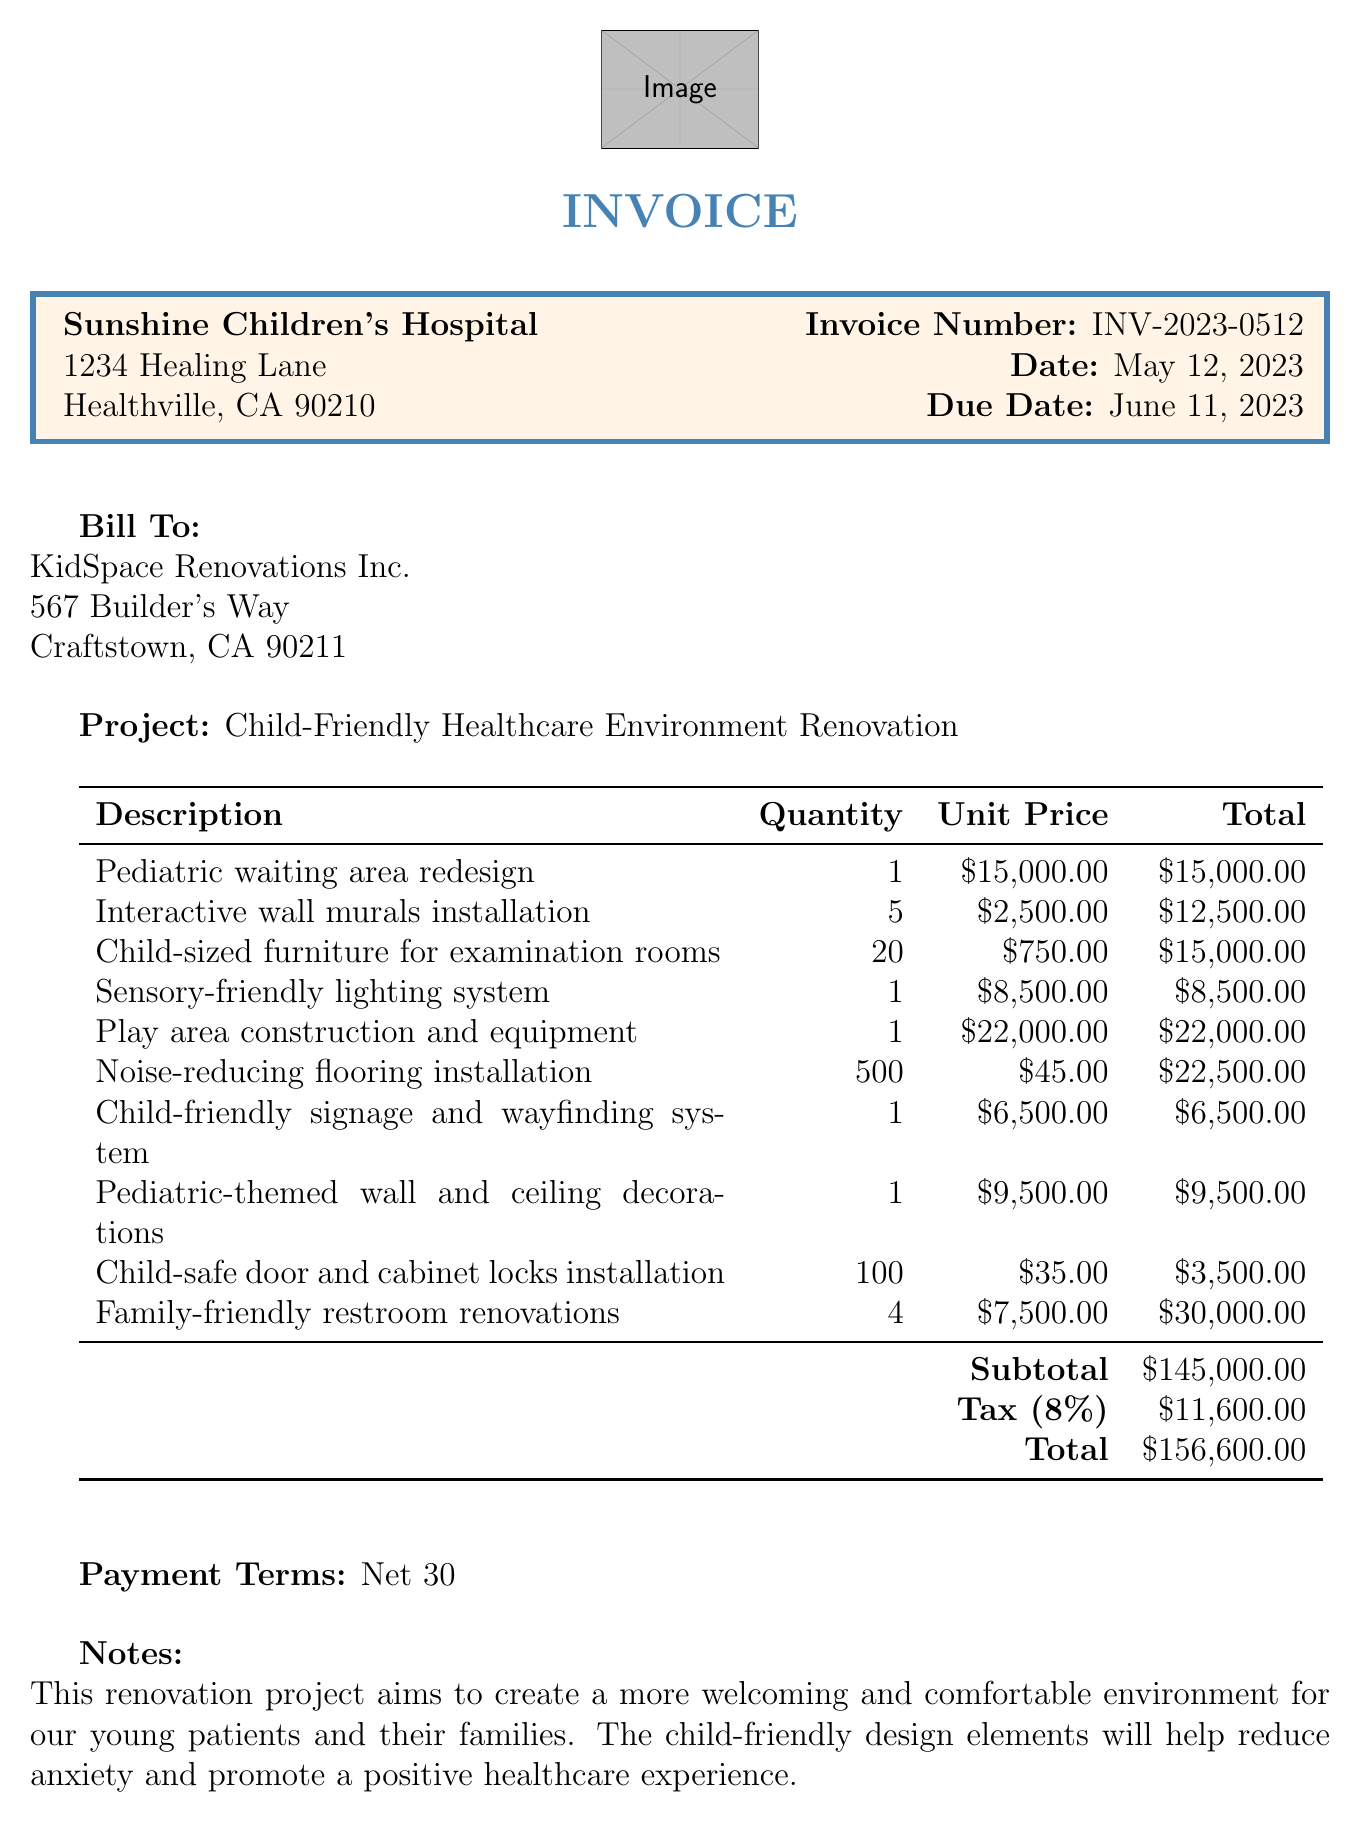What is the invoice number? The invoice number is listed clearly in the document, which is INV-2023-0512.
Answer: INV-2023-0512 What is the total amount for the renovation project? The total amount is summarized at the end of the line item details, amounting to $156,600.
Answer: $156,600 How many family-friendly restroom renovations are included? Family-friendly restroom renovations are listed as having a quantity of 4 in the line items.
Answer: 4 What is the tax rate applied to the subtotal? The tax rate of 8% is specified in the tax calculation section of the document.
Answer: 8% Who is the project manager? The project manager's name is given at the bottom of the document, which is Emily Thompson.
Answer: Emily Thompson What is the due date for the invoice payment? The due date for payment is clearly stated as June 11, 2023, in the document.
Answer: June 11, 2023 How many child-safe door and cabinet locks were installed? The line item specifies that 100 child-safe door and cabinet locks were installed.
Answer: 100 What is the quantity of interactive wall murals installed? The quantity of interactive wall murals specified in the renovation details is 5.
Answer: 5 What is the purpose of the renovation project as stated in the notes? The notes specifically mention that the purpose is to create a more welcoming and comfortable environment for young patients and their families.
Answer: A welcoming and comfortable environment for young patients and their families 